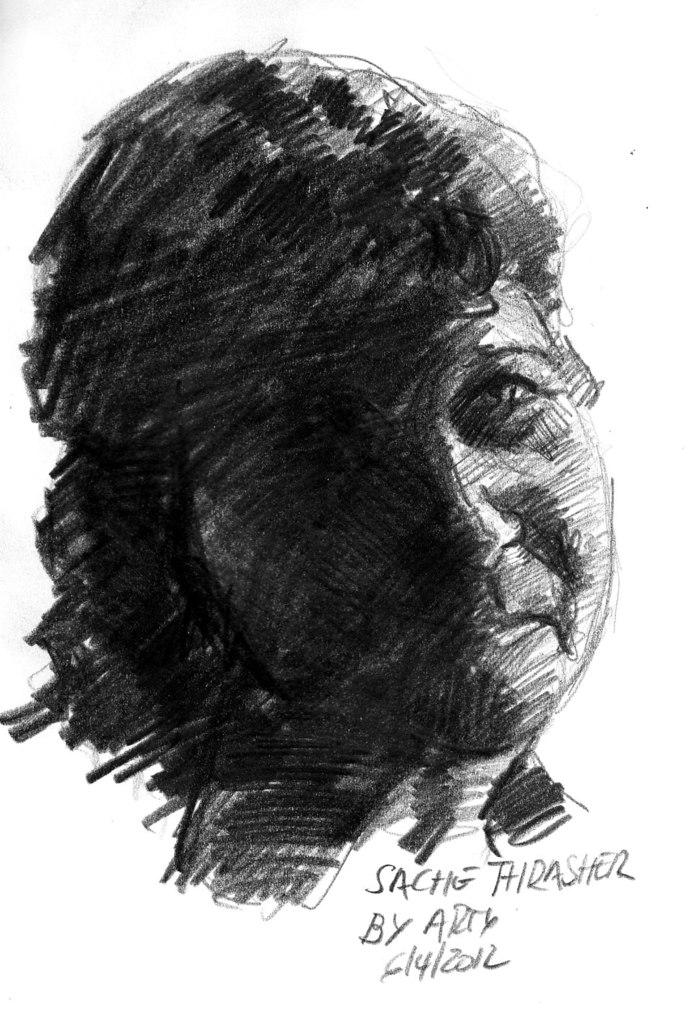What is depicted in the image? There is a sketch of a person in the image. What else can be found in the image? There is handwritten text in the image. How many owls are sitting on the shelves in the store depicted in the image? There is no store or owls present in the image; it features a sketch of a person and handwritten text. 